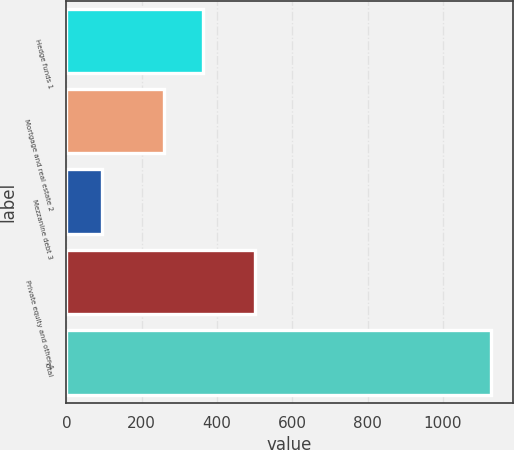<chart> <loc_0><loc_0><loc_500><loc_500><bar_chart><fcel>Hedge funds 1<fcel>Mortgage and real estate 2<fcel>Mezzanine debt 3<fcel>Private equity and other 4<fcel>Total<nl><fcel>362.4<fcel>259<fcel>95<fcel>502<fcel>1129<nl></chart> 